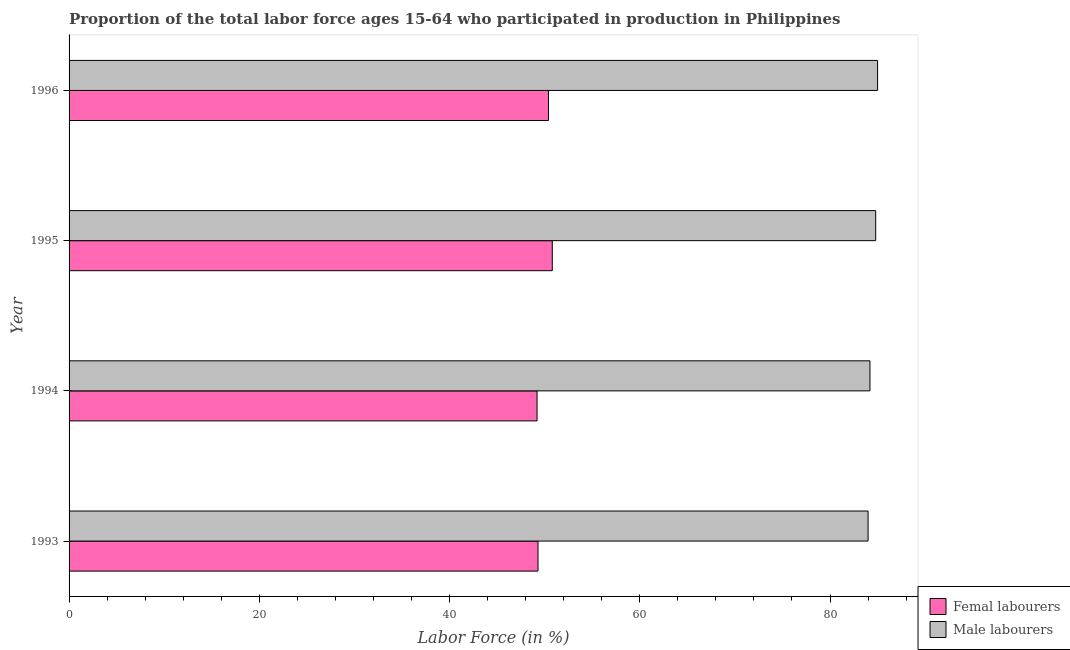How many different coloured bars are there?
Provide a short and direct response. 2. How many groups of bars are there?
Give a very brief answer. 4. Are the number of bars per tick equal to the number of legend labels?
Make the answer very short. Yes. What is the label of the 4th group of bars from the top?
Your answer should be very brief. 1993. In how many cases, is the number of bars for a given year not equal to the number of legend labels?
Keep it short and to the point. 0. What is the percentage of female labor force in 1996?
Offer a terse response. 50.4. Across all years, what is the maximum percentage of female labor force?
Ensure brevity in your answer.  50.8. What is the total percentage of male labour force in the graph?
Keep it short and to the point. 338. What is the difference between the percentage of female labor force in 1994 and that in 1996?
Offer a terse response. -1.2. What is the difference between the percentage of male labour force in 1995 and the percentage of female labor force in 1994?
Your answer should be compact. 35.6. What is the average percentage of male labour force per year?
Offer a terse response. 84.5. In the year 1994, what is the difference between the percentage of male labour force and percentage of female labor force?
Make the answer very short. 35. Is the difference between the percentage of female labor force in 1993 and 1996 greater than the difference between the percentage of male labour force in 1993 and 1996?
Give a very brief answer. No. What is the difference between the highest and the lowest percentage of male labour force?
Your answer should be very brief. 1. What does the 2nd bar from the top in 1994 represents?
Ensure brevity in your answer.  Femal labourers. What does the 1st bar from the bottom in 1994 represents?
Your answer should be compact. Femal labourers. Are all the bars in the graph horizontal?
Ensure brevity in your answer.  Yes. Are the values on the major ticks of X-axis written in scientific E-notation?
Your response must be concise. No. Does the graph contain grids?
Make the answer very short. No. How many legend labels are there?
Your answer should be very brief. 2. What is the title of the graph?
Provide a short and direct response. Proportion of the total labor force ages 15-64 who participated in production in Philippines. What is the label or title of the Y-axis?
Give a very brief answer. Year. What is the Labor Force (in %) of Femal labourers in 1993?
Keep it short and to the point. 49.3. What is the Labor Force (in %) in Femal labourers in 1994?
Give a very brief answer. 49.2. What is the Labor Force (in %) of Male labourers in 1994?
Ensure brevity in your answer.  84.2. What is the Labor Force (in %) of Femal labourers in 1995?
Provide a succinct answer. 50.8. What is the Labor Force (in %) of Male labourers in 1995?
Your answer should be very brief. 84.8. What is the Labor Force (in %) in Femal labourers in 1996?
Ensure brevity in your answer.  50.4. Across all years, what is the maximum Labor Force (in %) in Femal labourers?
Your response must be concise. 50.8. Across all years, what is the minimum Labor Force (in %) in Femal labourers?
Your answer should be very brief. 49.2. What is the total Labor Force (in %) of Femal labourers in the graph?
Keep it short and to the point. 199.7. What is the total Labor Force (in %) of Male labourers in the graph?
Give a very brief answer. 338. What is the difference between the Labor Force (in %) in Femal labourers in 1993 and that in 1994?
Your answer should be very brief. 0.1. What is the difference between the Labor Force (in %) of Femal labourers in 1993 and that in 1995?
Your response must be concise. -1.5. What is the difference between the Labor Force (in %) of Male labourers in 1994 and that in 1995?
Ensure brevity in your answer.  -0.6. What is the difference between the Labor Force (in %) in Femal labourers in 1994 and that in 1996?
Offer a terse response. -1.2. What is the difference between the Labor Force (in %) of Femal labourers in 1995 and that in 1996?
Offer a terse response. 0.4. What is the difference between the Labor Force (in %) in Femal labourers in 1993 and the Labor Force (in %) in Male labourers in 1994?
Offer a very short reply. -34.9. What is the difference between the Labor Force (in %) in Femal labourers in 1993 and the Labor Force (in %) in Male labourers in 1995?
Offer a very short reply. -35.5. What is the difference between the Labor Force (in %) in Femal labourers in 1993 and the Labor Force (in %) in Male labourers in 1996?
Give a very brief answer. -35.7. What is the difference between the Labor Force (in %) in Femal labourers in 1994 and the Labor Force (in %) in Male labourers in 1995?
Provide a succinct answer. -35.6. What is the difference between the Labor Force (in %) of Femal labourers in 1994 and the Labor Force (in %) of Male labourers in 1996?
Your answer should be compact. -35.8. What is the difference between the Labor Force (in %) of Femal labourers in 1995 and the Labor Force (in %) of Male labourers in 1996?
Provide a short and direct response. -34.2. What is the average Labor Force (in %) in Femal labourers per year?
Provide a succinct answer. 49.92. What is the average Labor Force (in %) of Male labourers per year?
Provide a succinct answer. 84.5. In the year 1993, what is the difference between the Labor Force (in %) in Femal labourers and Labor Force (in %) in Male labourers?
Provide a short and direct response. -34.7. In the year 1994, what is the difference between the Labor Force (in %) of Femal labourers and Labor Force (in %) of Male labourers?
Offer a very short reply. -35. In the year 1995, what is the difference between the Labor Force (in %) of Femal labourers and Labor Force (in %) of Male labourers?
Ensure brevity in your answer.  -34. In the year 1996, what is the difference between the Labor Force (in %) of Femal labourers and Labor Force (in %) of Male labourers?
Make the answer very short. -34.6. What is the ratio of the Labor Force (in %) of Femal labourers in 1993 to that in 1994?
Give a very brief answer. 1. What is the ratio of the Labor Force (in %) of Male labourers in 1993 to that in 1994?
Ensure brevity in your answer.  1. What is the ratio of the Labor Force (in %) of Femal labourers in 1993 to that in 1995?
Your answer should be very brief. 0.97. What is the ratio of the Labor Force (in %) in Male labourers in 1993 to that in 1995?
Give a very brief answer. 0.99. What is the ratio of the Labor Force (in %) in Femal labourers in 1993 to that in 1996?
Keep it short and to the point. 0.98. What is the ratio of the Labor Force (in %) of Male labourers in 1993 to that in 1996?
Provide a succinct answer. 0.99. What is the ratio of the Labor Force (in %) of Femal labourers in 1994 to that in 1995?
Ensure brevity in your answer.  0.97. What is the ratio of the Labor Force (in %) of Male labourers in 1994 to that in 1995?
Provide a succinct answer. 0.99. What is the ratio of the Labor Force (in %) in Femal labourers in 1994 to that in 1996?
Keep it short and to the point. 0.98. What is the ratio of the Labor Force (in %) in Male labourers in 1994 to that in 1996?
Offer a very short reply. 0.99. What is the ratio of the Labor Force (in %) in Femal labourers in 1995 to that in 1996?
Ensure brevity in your answer.  1.01. What is the ratio of the Labor Force (in %) in Male labourers in 1995 to that in 1996?
Your response must be concise. 1. What is the difference between the highest and the second highest Labor Force (in %) in Femal labourers?
Give a very brief answer. 0.4. What is the difference between the highest and the second highest Labor Force (in %) in Male labourers?
Make the answer very short. 0.2. 